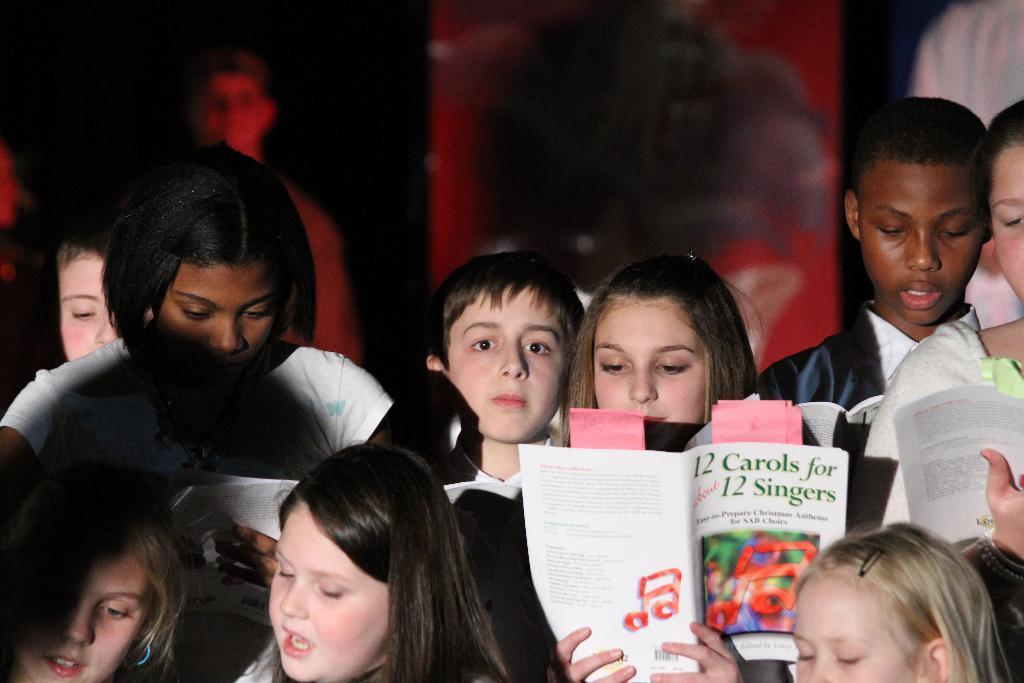How would you summarize this image in a sentence or two? There are people holding books. In the background it is dark and we can see a person. 